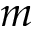<formula> <loc_0><loc_0><loc_500><loc_500>m</formula> 